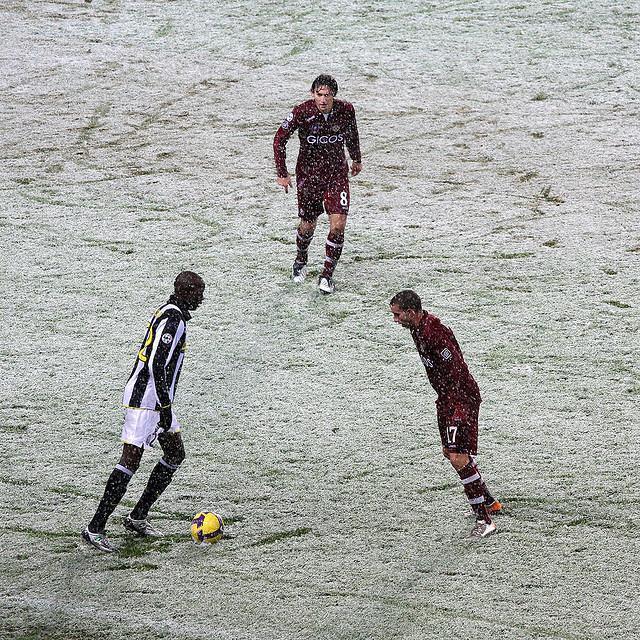How many people can you see?
Give a very brief answer. 3. 